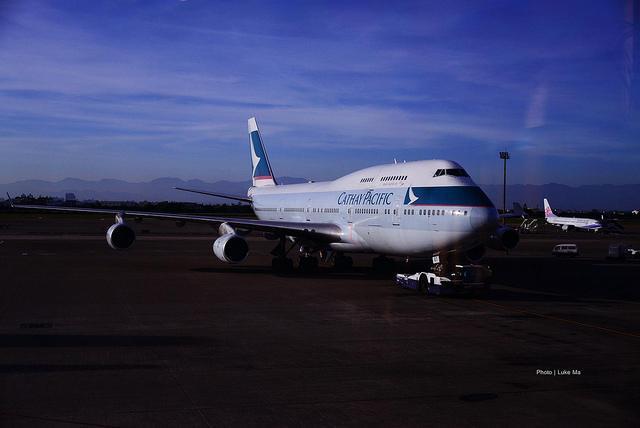How many colors is the plane's tail?
Give a very brief answer. 3. How many airplanes are in the photo?
Give a very brief answer. 1. 